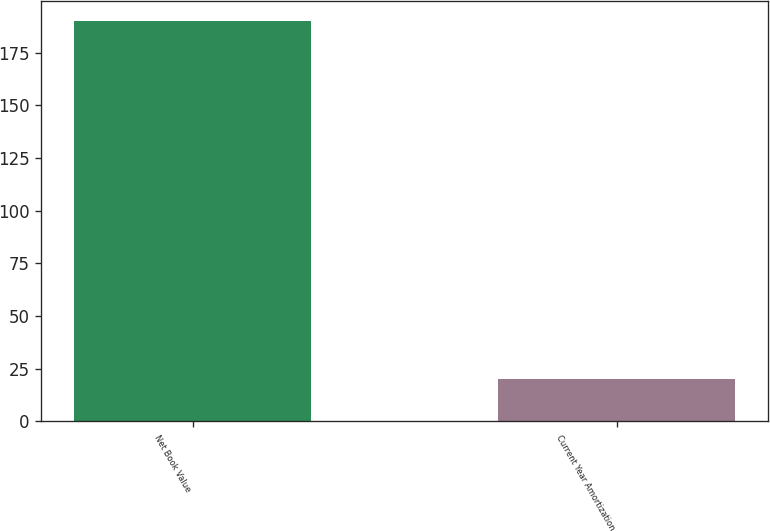Convert chart to OTSL. <chart><loc_0><loc_0><loc_500><loc_500><bar_chart><fcel>Net Book Value<fcel>Current Year Amortization<nl><fcel>190<fcel>20<nl></chart> 